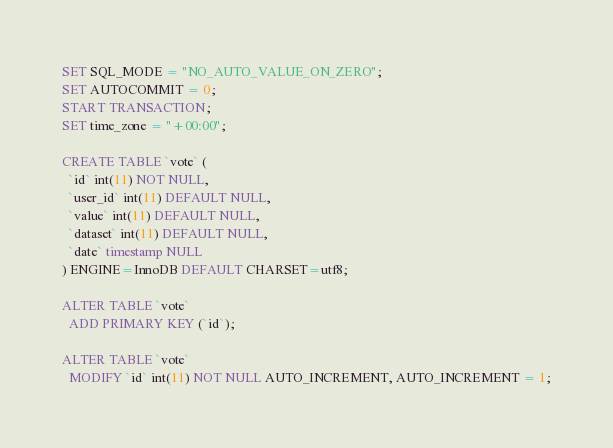<code> <loc_0><loc_0><loc_500><loc_500><_SQL_>SET SQL_MODE = "NO_AUTO_VALUE_ON_ZERO";
SET AUTOCOMMIT = 0;
START TRANSACTION;
SET time_zone = "+00:00";

CREATE TABLE `vote` (
  `id` int(11) NOT NULL,
  `user_id` int(11) DEFAULT NULL,
  `value` int(11) DEFAULT NULL,
  `dataset` int(11) DEFAULT NULL,
  `date` timestamp NULL
) ENGINE=InnoDB DEFAULT CHARSET=utf8;

ALTER TABLE `vote`
  ADD PRIMARY KEY (`id`);

ALTER TABLE `vote`
  MODIFY `id` int(11) NOT NULL AUTO_INCREMENT, AUTO_INCREMENT = 1;
</code> 